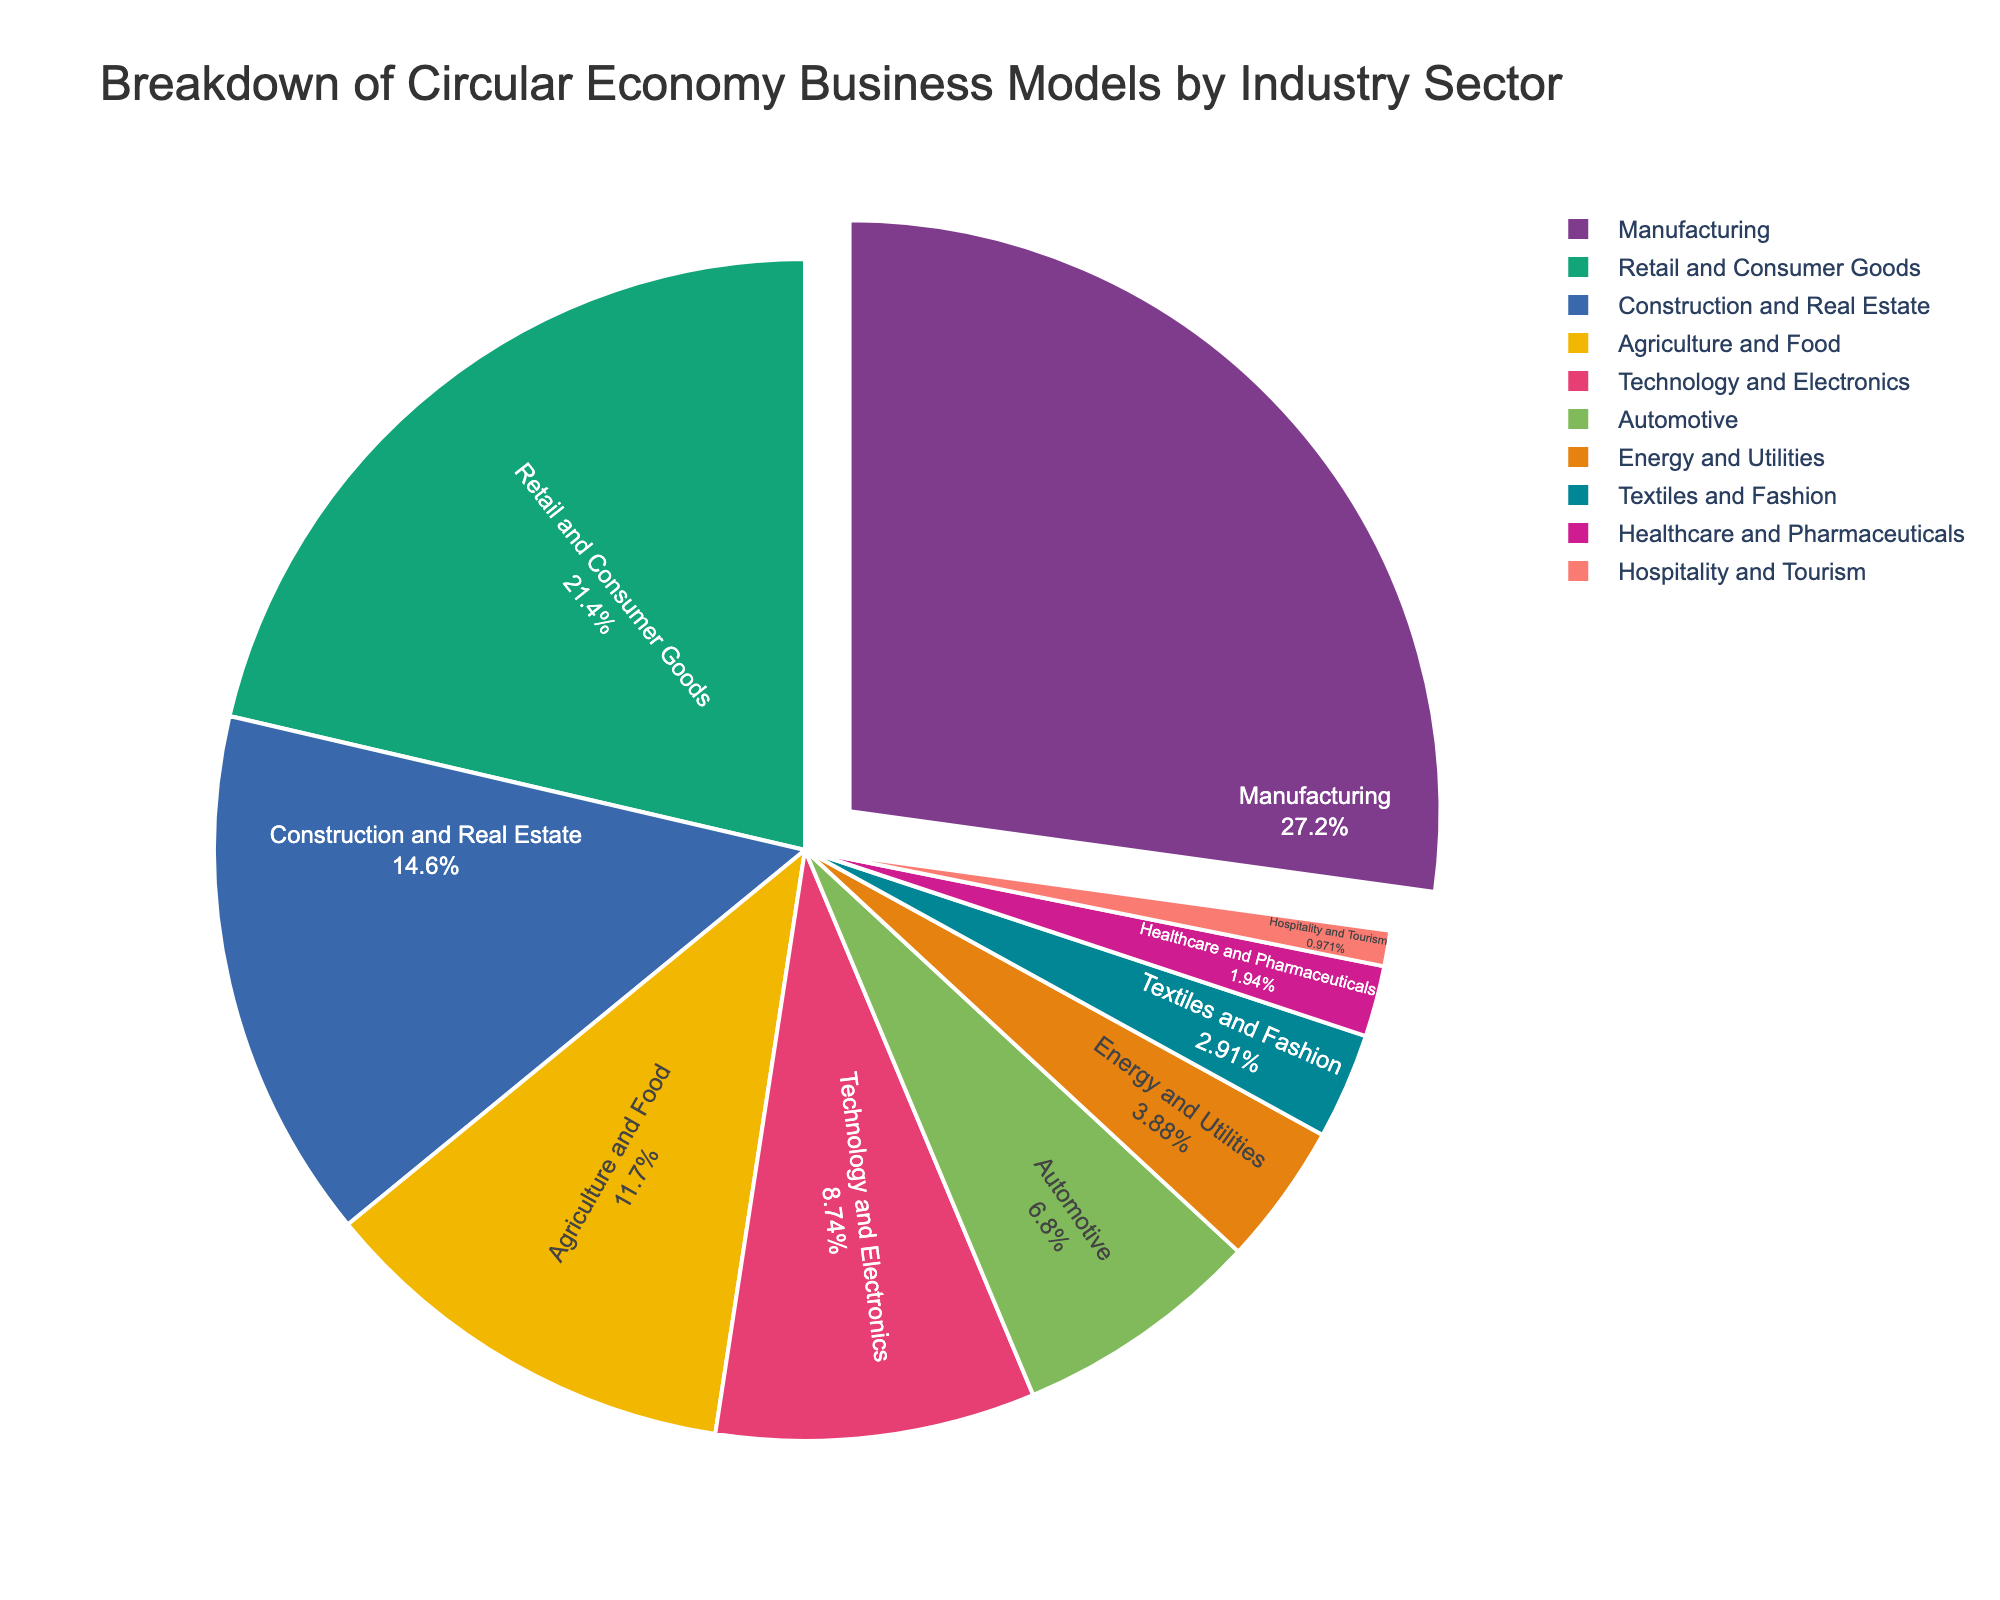What industry sector holds the highest percentage in the circular economy business models? The Manufacturing sector has the highest percentage, which is represented by the largest slice in the pie chart.
Answer: Manufacturing What is the combined percentage of the Manufacturing and Retail and Consumer Goods sectors? The Manufacturing sector is 28% and the Retail and Consumer Goods sector is 22%. Adding these together gives 28% + 22% = 50%.
Answer: 50% Which industry sectors have a percentage of 4% or lower? The sectors with percentages of 4% or lower are Energy and Utilities (4%), Textiles and Fashion (3%), Healthcare and Pharmaceuticals (2%), and Hospitality and Tourism (1%).
Answer: Energy and Utilities, Textiles and Fashion, Healthcare and Pharmaceuticals, Hospitality and Tourism How much larger is the percentage of the Manufacturing sector compared to the Technology and Electronics sector? The Manufacturing sector is 28% and the Technology and Electronics sector is 9%. The difference is 28% - 9% = 19%.
Answer: 19% What is the smallest industry sector represented in this pie chart? The smallest industry sector is Hospitality and Tourism, with a percentage of 1%.
Answer: Hospitality and Tourism How does the percentage of the Automotive sector compare to that of the Agriculture and Food sector? The Automotive sector is 7% while the Agriculture and Food sector is 12%. The Automotive sector is 5% less than the Agriculture and Food sector.
Answer: The Automotive sector is 5% less If you were to highlight the top three sectors, which would they be? The top three sectors, based on the largest slices in the pie chart, are Manufacturing (28%), Retail and Consumer Goods (22%), and Construction and Real Estate (15%).
Answer: Manufacturing, Retail and Consumer Goods, Construction and Real Estate Which sectors together make up less than 10% of the pie chart? The sectors with percentages summing up to less than 10% are Textiles and Fashion (3%), Healthcare and Pharmaceuticals (2%), and Hospitality and Tourism (1%). Together, they make 3% + 2% + 1% = 6%.
Answer: Textiles and Fashion, Healthcare and Pharmaceuticals, Hospitality and Tourism 